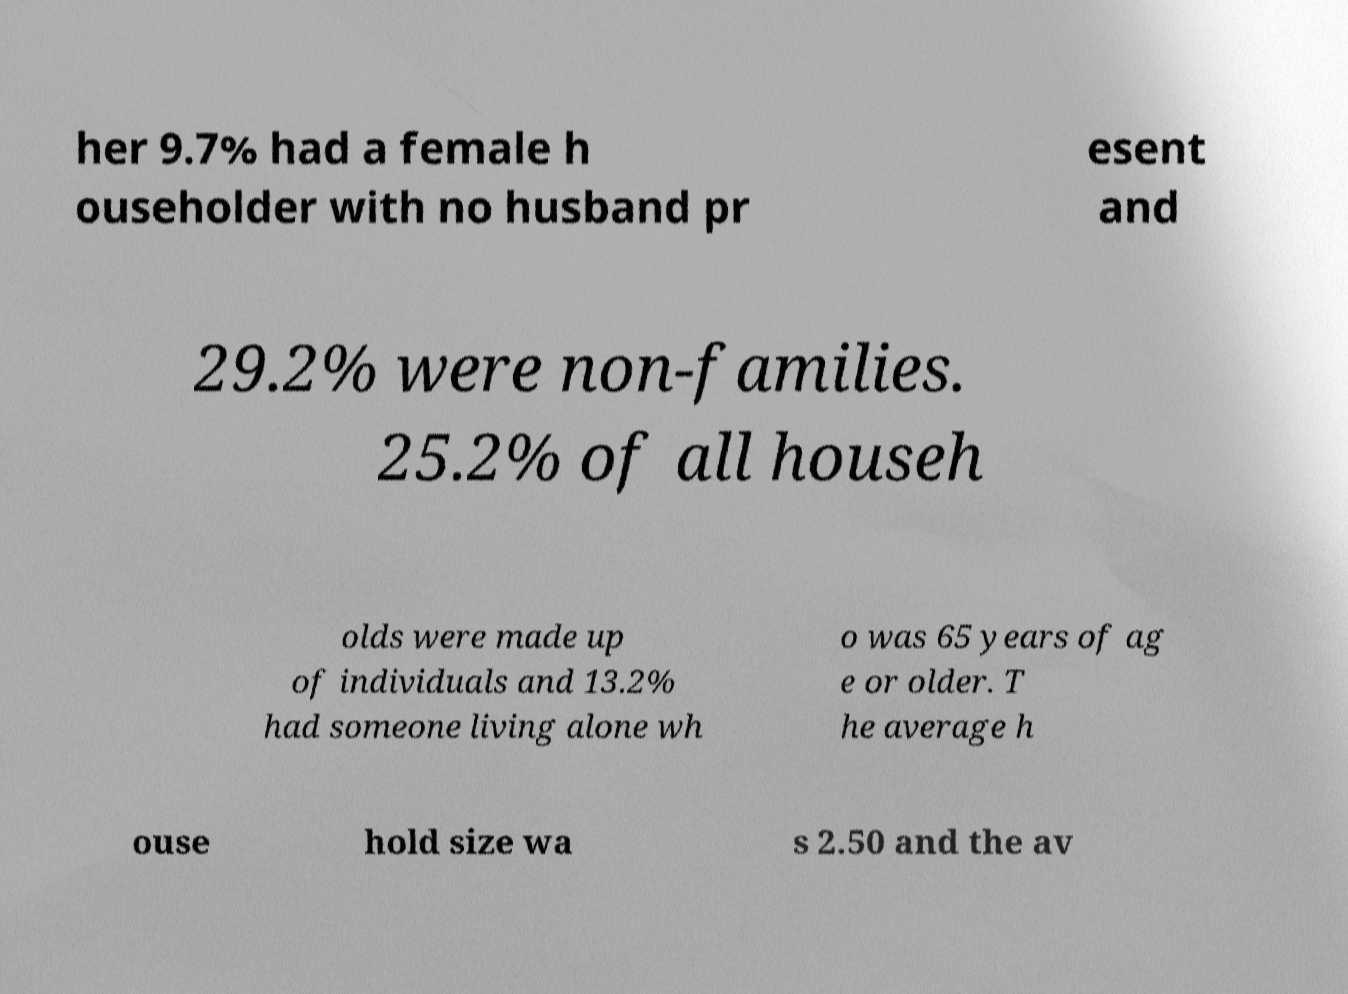Could you assist in decoding the text presented in this image and type it out clearly? her 9.7% had a female h ouseholder with no husband pr esent and 29.2% were non-families. 25.2% of all househ olds were made up of individuals and 13.2% had someone living alone wh o was 65 years of ag e or older. T he average h ouse hold size wa s 2.50 and the av 